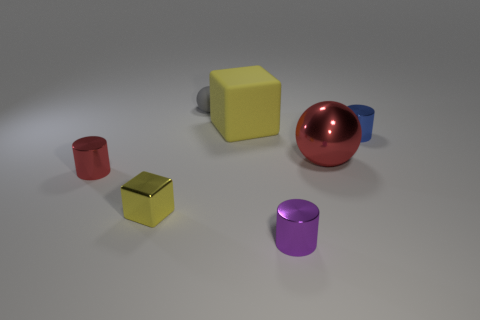Add 1 big gray metal blocks. How many objects exist? 8 Subtract all blocks. How many objects are left? 5 Subtract all large brown balls. Subtract all shiny blocks. How many objects are left? 6 Add 2 gray objects. How many gray objects are left? 3 Add 2 tiny gray rubber objects. How many tiny gray rubber objects exist? 3 Subtract 0 brown cubes. How many objects are left? 7 